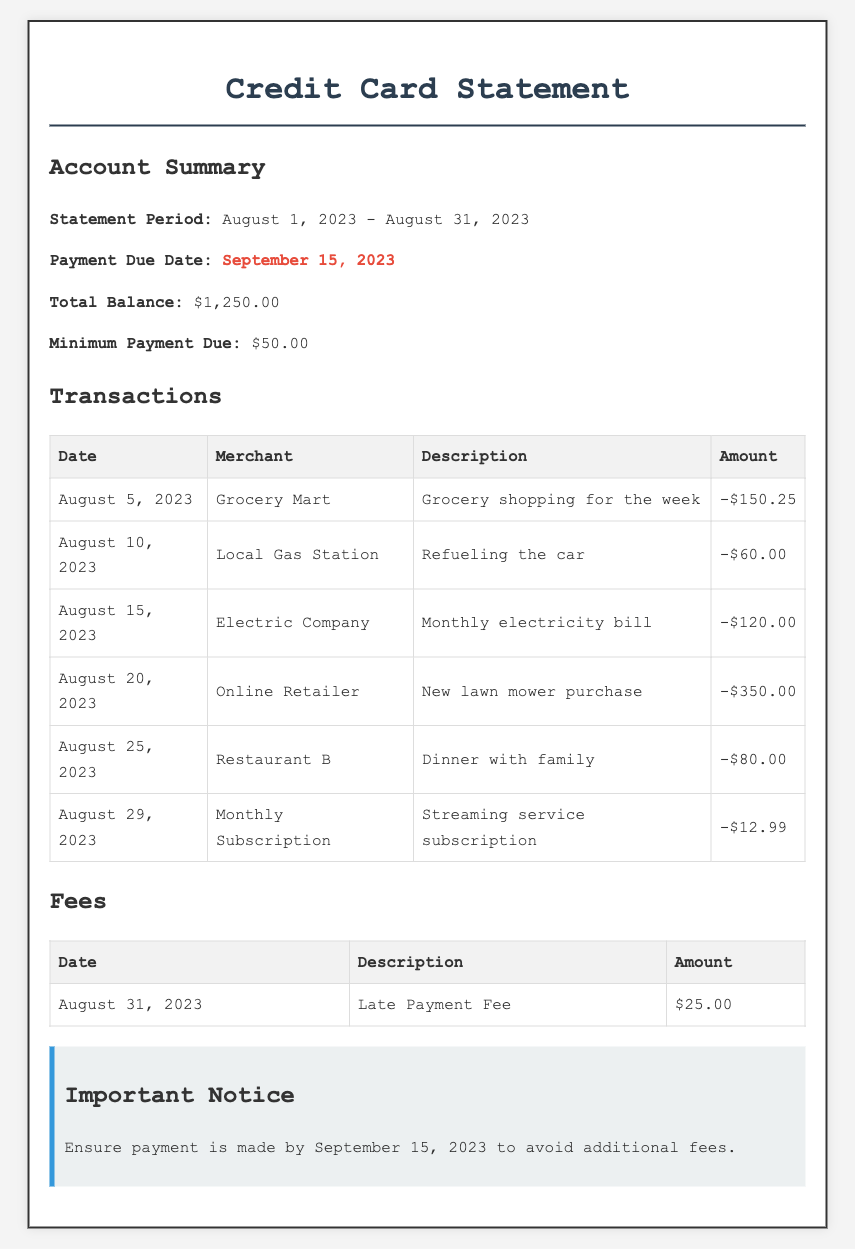What is the statement period? The statement period is mentioned in the document as the duration during which the transactions were made. It is from August 1, 2023 to August 31, 2023.
Answer: August 1, 2023 - August 31, 2023 What is the payment due date? The payment due date is specified in the summary section and indicates when the next payment should be made to avoid penalties.
Answer: September 15, 2023 What is the total balance? The total balance represents the amount owed on the credit card at the end of the statement period, as shown in the summary.
Answer: $1,250.00 How much is the minimum payment due? The document states the smallest amount that should be paid by the due date to keep the account in good standing, found in the summary section.
Answer: $50.00 What transaction occurred at the Grocery Mart on August 5, 2023? This transaction includes details about when and where the transaction took place along with its purpose, based on the transactions section.
Answer: Grocery shopping for the week What was the amount charged by the Online Retailer on August 20, 2023? The amount charged is shown in the transactions table, associated with a specific merchant and date.
Answer: -$350.00 What was the description of the fee incurred on August 31, 2023? This fee description provides insight into the reason for the charge and is mentioned in the fees section of the document.
Answer: Late Payment Fee What is the total of the transactions listed? The total of the transactions is the sum of all amounts listed in the transactions table, reflecting total spending for the month.
Answer: Not computable from given data Why is it important to make the payment by the due date? The document emphasizes the significance of making the payment to avoid additional charges, reflecting good financial management.
Answer: To avoid additional fees 